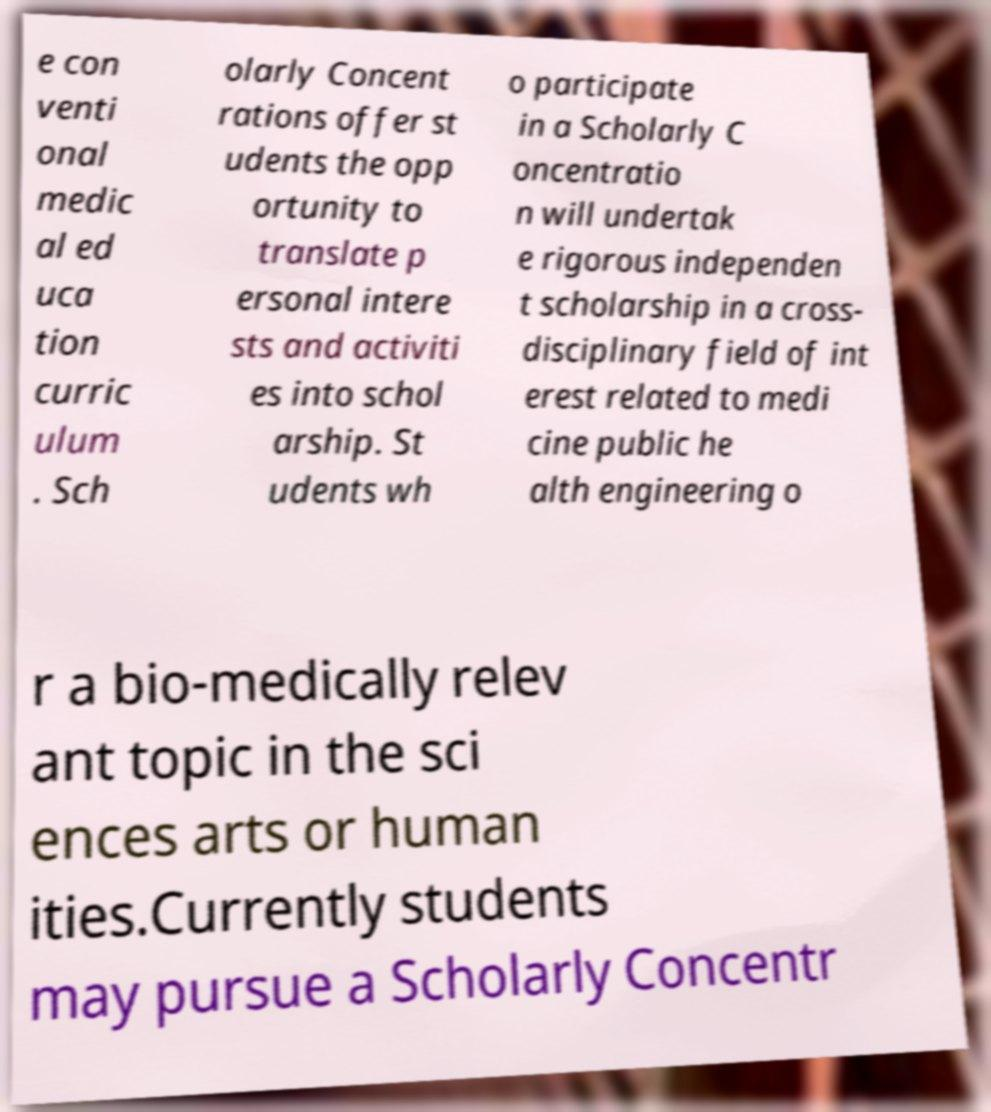I need the written content from this picture converted into text. Can you do that? e con venti onal medic al ed uca tion curric ulum . Sch olarly Concent rations offer st udents the opp ortunity to translate p ersonal intere sts and activiti es into schol arship. St udents wh o participate in a Scholarly C oncentratio n will undertak e rigorous independen t scholarship in a cross- disciplinary field of int erest related to medi cine public he alth engineering o r a bio-medically relev ant topic in the sci ences arts or human ities.Currently students may pursue a Scholarly Concentr 